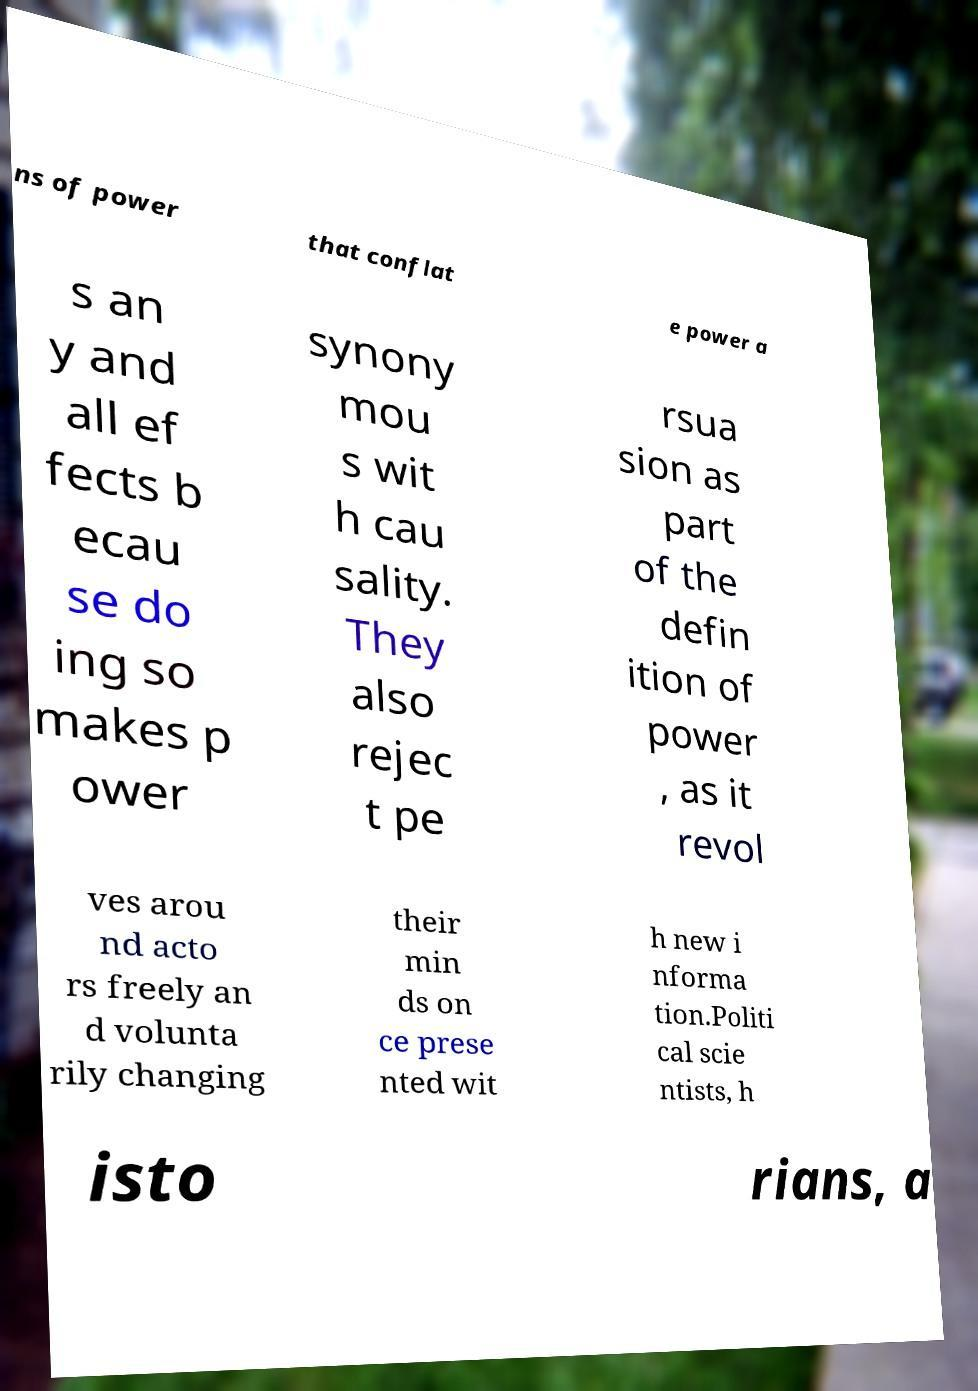Please read and relay the text visible in this image. What does it say? ns of power that conflat e power a s an y and all ef fects b ecau se do ing so makes p ower synony mou s wit h cau sality. They also rejec t pe rsua sion as part of the defin ition of power , as it revol ves arou nd acto rs freely an d volunta rily changing their min ds on ce prese nted wit h new i nforma tion.Politi cal scie ntists, h isto rians, a 